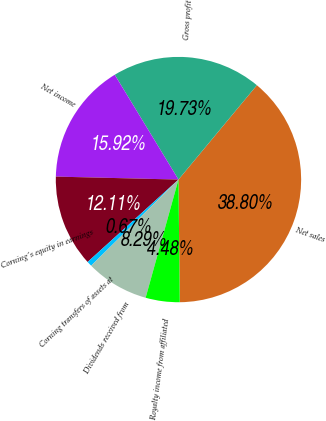<chart> <loc_0><loc_0><loc_500><loc_500><pie_chart><fcel>Net sales<fcel>Gross profit<fcel>Net income<fcel>Corning's equity in earnings<fcel>Corning transfers of assets at<fcel>Dividends received from<fcel>Royalty income from affiliated<nl><fcel>38.8%<fcel>19.73%<fcel>15.92%<fcel>12.11%<fcel>0.67%<fcel>8.29%<fcel>4.48%<nl></chart> 